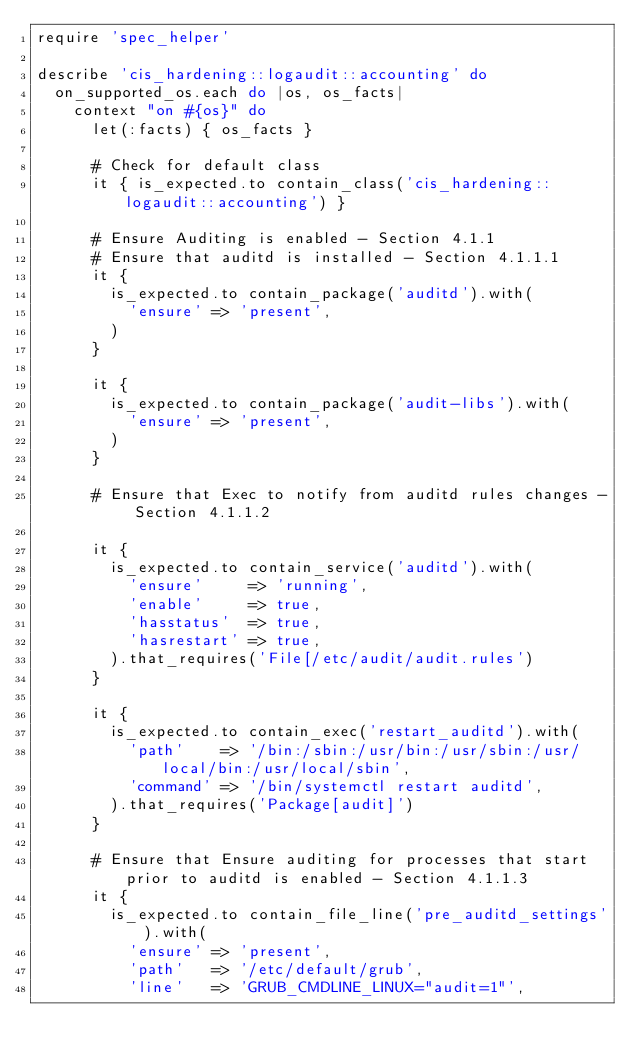<code> <loc_0><loc_0><loc_500><loc_500><_Ruby_>require 'spec_helper'

describe 'cis_hardening::logaudit::accounting' do
  on_supported_os.each do |os, os_facts|
    context "on #{os}" do
      let(:facts) { os_facts }

      # Check for default class
      it { is_expected.to contain_class('cis_hardening::logaudit::accounting') }

      # Ensure Auditing is enabled - Section 4.1.1
      # Ensure that auditd is installed - Section 4.1.1.1
      it {
        is_expected.to contain_package('auditd').with(
          'ensure' => 'present',
        )
      }

      it {
        is_expected.to contain_package('audit-libs').with(
          'ensure' => 'present',
        )
      }
      
      # Ensure that Exec to notify from auditd rules changes - Section 4.1.1.2

      it {
        is_expected.to contain_service('auditd').with(
          'ensure'     => 'running',
          'enable'     => true,
          'hasstatus'  => true,
          'hasrestart' => true,
        ).that_requires('File[/etc/audit/audit.rules')
      }

      it {
        is_expected.to contain_exec('restart_auditd').with(
          'path'    => '/bin:/sbin:/usr/bin:/usr/sbin:/usr/local/bin:/usr/local/sbin',
          'command' => '/bin/systemctl restart auditd',
        ).that_requires('Package[audit]')
      }

      # Ensure that Ensure auditing for processes that start prior to auditd is enabled - Section 4.1.1.3
      it {
        is_expected.to contain_file_line('pre_auditd_settings').with(
          'ensure' => 'present',
          'path'   => '/etc/default/grub',
          'line'   => 'GRUB_CMDLINE_LINUX="audit=1"',</code> 